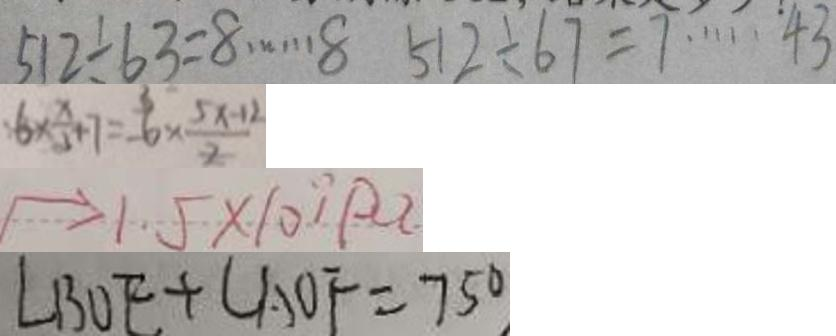Convert formula to latex. <formula><loc_0><loc_0><loc_500><loc_500>5 1 2 \div 6 3 = 8 \cdots 8 5 1 2 \div 6 7 = 7 \cdots 4 3 
 6 \times \frac { x } { 3 } + 7 = 6 \times \frac { 5 x - 1 2 } { 2 } 
 \rightarrow 1 . 5 \times 1 0 ^ { \prime } P a 
 \angle B O E + \angle A O F = 7 5 ^ { \circ }</formula> 